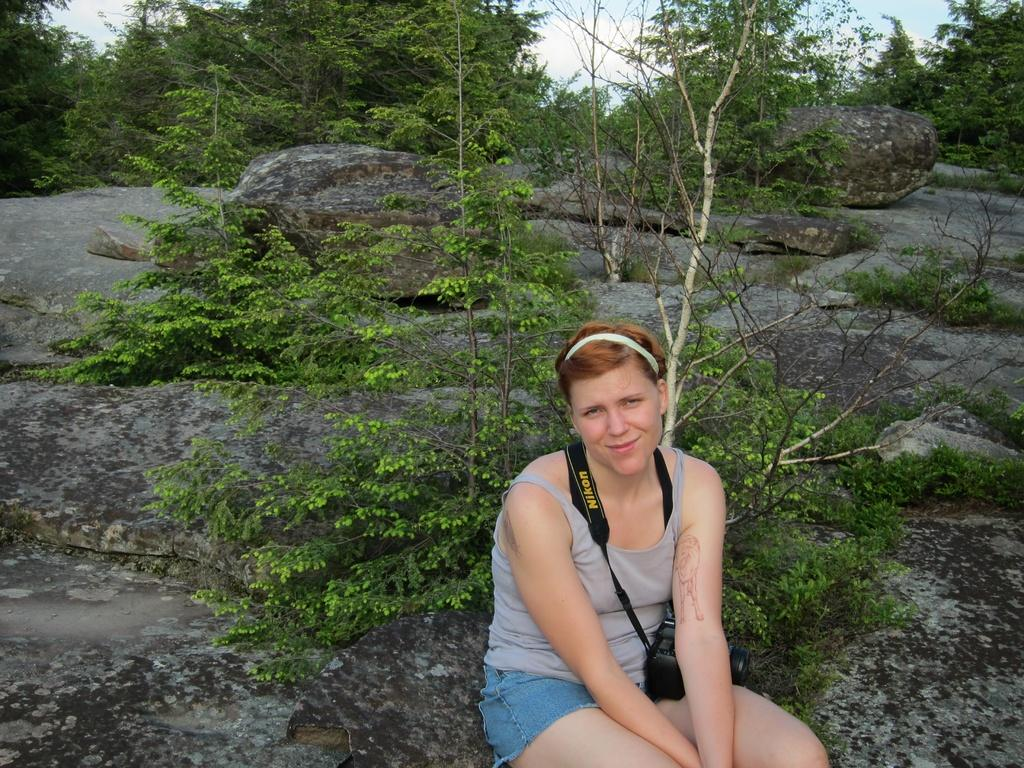What is the person in the image doing? The person is sitting on a rock in the image. What is the person wearing that is related to photography? The person is wearing a camera. What type of natural environment is visible behind the person? There are trees and rocks behind the person. What can be seen in the sky in the background of the image? The sky is visible in the background of the image. Can you see any wings on the person in the image? No, there are no wings visible on the person in the image. What type of thunder can be heard in the image? There is no sound, including thunder, present in the image, as it is a still photograph. 